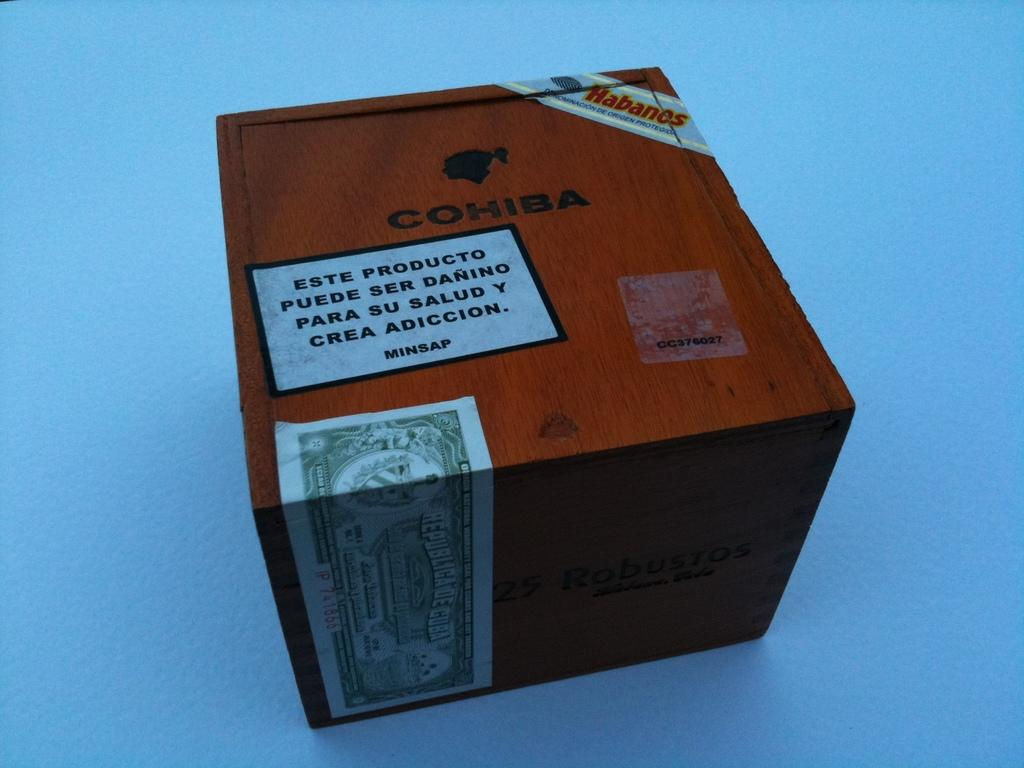<image>
Render a clear and concise summary of the photo. a sealed wooden box reading COHIBA and Habanos 